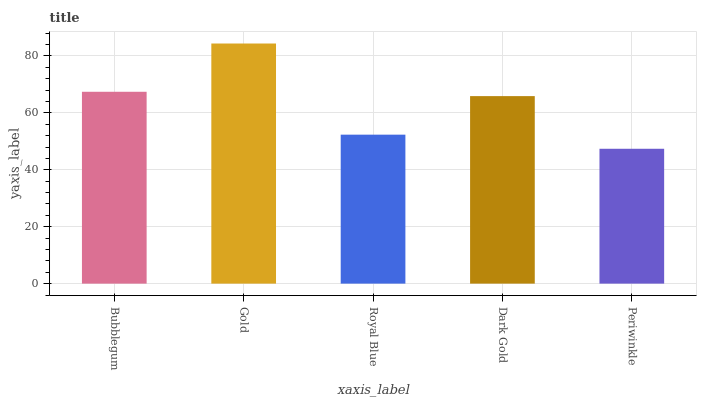Is Periwinkle the minimum?
Answer yes or no. Yes. Is Gold the maximum?
Answer yes or no. Yes. Is Royal Blue the minimum?
Answer yes or no. No. Is Royal Blue the maximum?
Answer yes or no. No. Is Gold greater than Royal Blue?
Answer yes or no. Yes. Is Royal Blue less than Gold?
Answer yes or no. Yes. Is Royal Blue greater than Gold?
Answer yes or no. No. Is Gold less than Royal Blue?
Answer yes or no. No. Is Dark Gold the high median?
Answer yes or no. Yes. Is Dark Gold the low median?
Answer yes or no. Yes. Is Royal Blue the high median?
Answer yes or no. No. Is Periwinkle the low median?
Answer yes or no. No. 